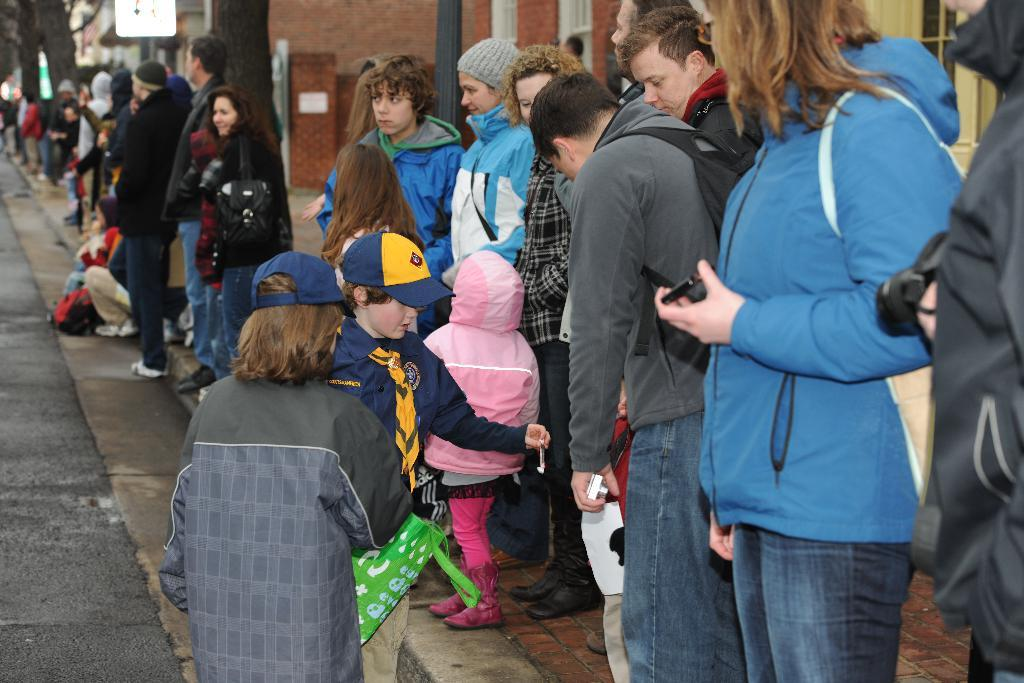What are the people in the image doing? There are people standing and sitting in the image. What can be seen in the background of the image? Trees and buildings are visible in the background of the image. What type of cracker is being used to hold up the earth in the image? There is no cracker or reference to the earth in the image; it only features people and background elements. 